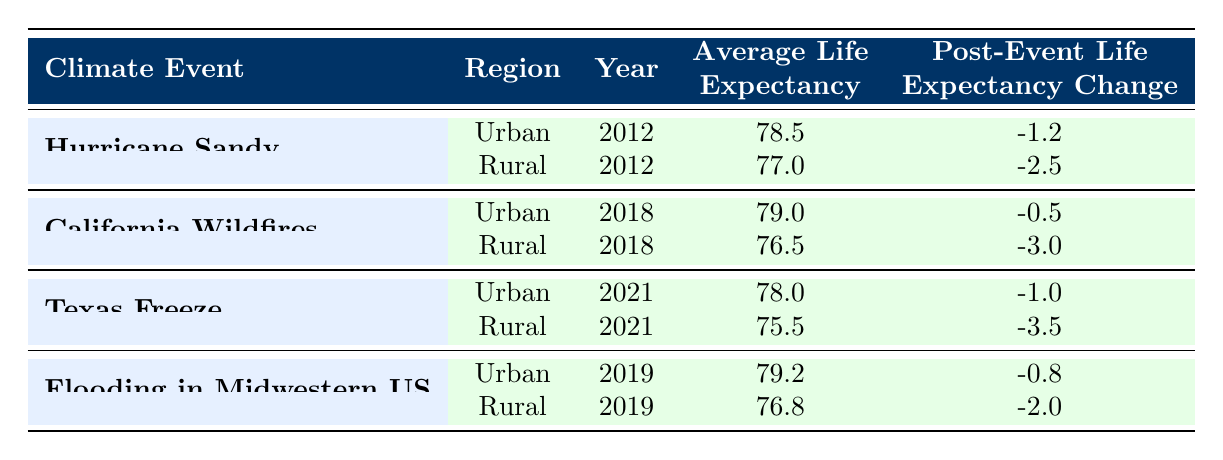What was the average life expectancy in urban areas after Hurricane Sandy? The table shows that in urban areas, the average life expectancy after Hurricane Sandy in 2012 was 78.5 years.
Answer: 78.5 What was the post-event change in life expectancy for rural areas following the California Wildfires? The data indicates that for rural areas after the California Wildfires in 2018, the post-event life expectancy change was -3.0 years.
Answer: -3.0 Was the average life expectancy greater in urban areas for the Texas Freeze event compared to rural areas? According to the table, for the Texas Freeze in 2021, the urban average life expectancy was 78.0 years, while rural areas had an average of 75.5 years, indicating that urban areas had a greater life expectancy.
Answer: Yes What is the difference in average life expectancy between urban and rural areas after the Flooding in Midwestern US? For this event in 2019, urban areas had an average life expectancy of 79.2 years, while rural areas had 76.8 years. The difference is calculated as 79.2 - 76.8 = 2.4 years.
Answer: 2.4 How did the average life expectancy change in urban areas from Hurricane Sandy to the Texas Freeze? The average life expectancy in urban areas after Hurricane Sandy was 78.5 years, and after the Texas Freeze, it was 78.0 years. The change is calculated as 78.0 - 78.5 = -0.5 years.
Answer: -0.5 Was the life expectancy change greater for rural areas after Hurricane Sandy compared to the Texas Freeze? The life expectancy change for rural areas after Hurricane Sandy was -2.5 years, while after the Texas Freeze it was -3.5 years. Since -3.5 is less than -2.5, the change was indeed greater after the Texas Freeze.
Answer: Yes What was the average life expectancy in rural areas for the Flooding in Midwestern US event? The table shows that in rural areas, the average life expectancy for the Flooding in Midwestern US in 2019 was 76.8 years.
Answer: 76.8 Compare the average life expectancies between urban and rural areas for all four events. In urban areas, the average life expectancies were 78.5 for Hurricane Sandy, 79.0 for California Wildfires, 78.0 for Texas Freeze, and 79.2 for Flooding in Midwestern US. In rural areas, they were 77.0, 76.5, 75.5, and 76.8 respectively. So, urban areas consistently showed higher average life expectancy values across all events compared to rural areas.
Answer: Urban areas had consistently higher life expectancies 